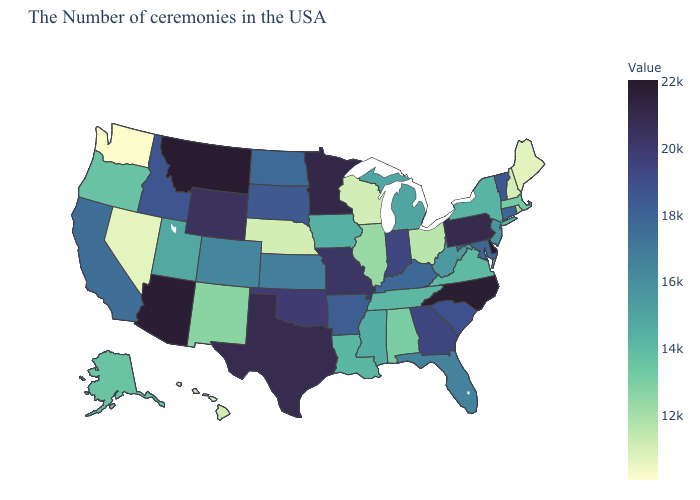Does Montana have the lowest value in the West?
Be succinct. No. Which states have the highest value in the USA?
Quick response, please. Delaware. Which states have the lowest value in the South?
Keep it brief. Alabama. Does Delaware have the highest value in the USA?
Give a very brief answer. Yes. Among the states that border Wisconsin , which have the highest value?
Answer briefly. Minnesota. Which states hav the highest value in the MidWest?
Answer briefly. Minnesota. 